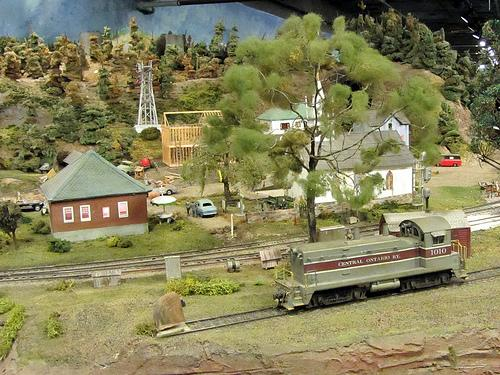Mention the objects that are part of this scene but unfinished or under construction. The wooden frame of an unfinished building and an unfinished house being constructed. Approximately, how many houses are there in the image? There are about three houses in the image, including a brown house, a white church, and an unfinished house. What are the two dominant colors of the ground? The ground is primarily green and brown. What is the color of the train and what is it doing? The train is green and rust-colored, and it is parked on the tracks. How many trees are there approximately in the image? There are many trees scattered throughout the image. Describe the emotions or mood that this image evokes. The image has a peaceful and serene mood, showcasing a picturesque model town and train scene. What type of location is depicted in the image? A town with a model train, houses, cars, trees, and other objects. What material is the communication tower made of? The communication tower is made of steel. Identify the colors of the house with green trim. The house is brown with green trim. Write a brief description of the most prominent objects in the image. A green train on tracks, a brown house with green roof, a blue car, a red car, a white church, a steel communication tower, trees, and a dark blue cloudy sky. 